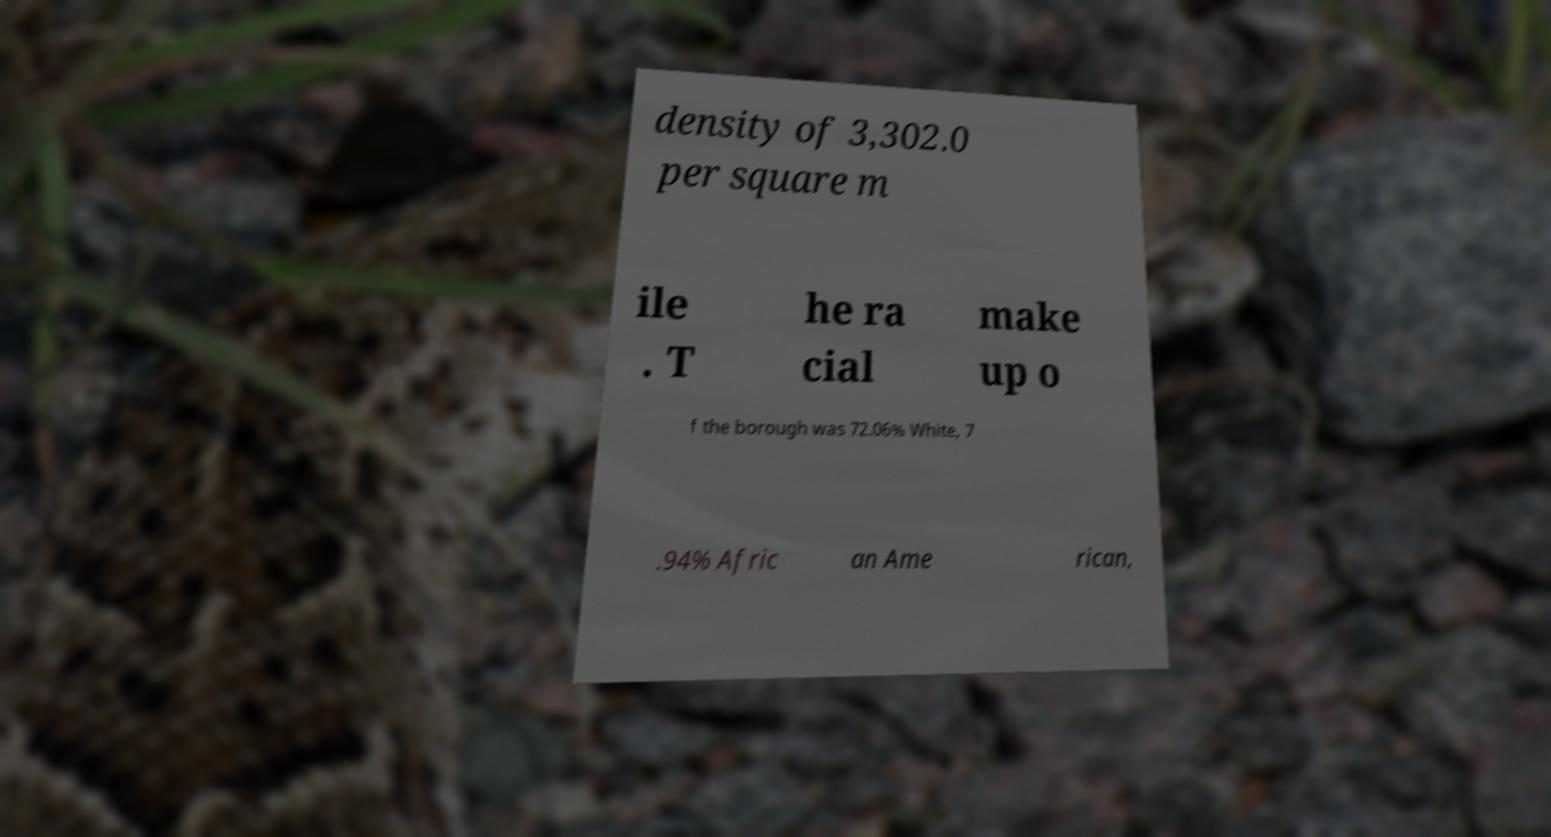Can you accurately transcribe the text from the provided image for me? density of 3,302.0 per square m ile . T he ra cial make up o f the borough was 72.06% White, 7 .94% Afric an Ame rican, 